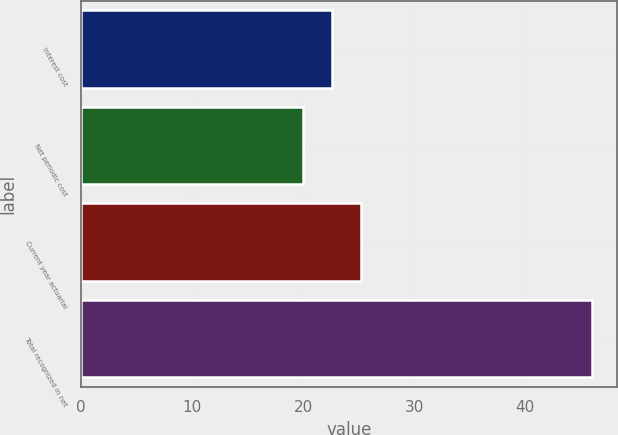Convert chart. <chart><loc_0><loc_0><loc_500><loc_500><bar_chart><fcel>Interest cost<fcel>Net periodic cost<fcel>Current year actuarial<fcel>Total recognized in net<nl><fcel>22.6<fcel>20<fcel>25.2<fcel>46<nl></chart> 